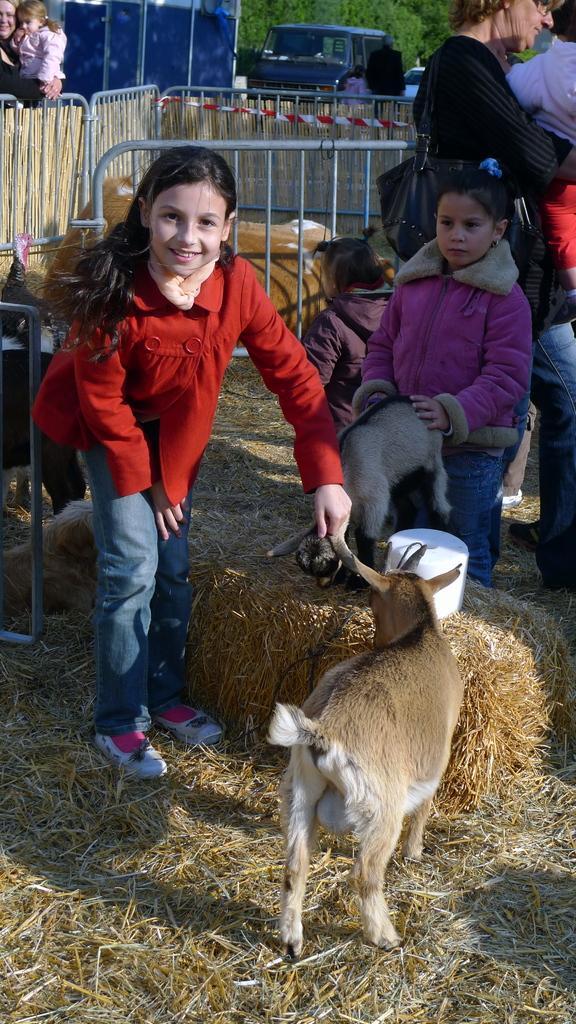Can you describe this image briefly? In this image in the front there is an animal standing. In the center there are persons. On the left side there is a girl standing and smiling and in the background there is a fence and there is an animal in the center. In the background there are persons, trees and there is a car. On the ground there is dry grass. 